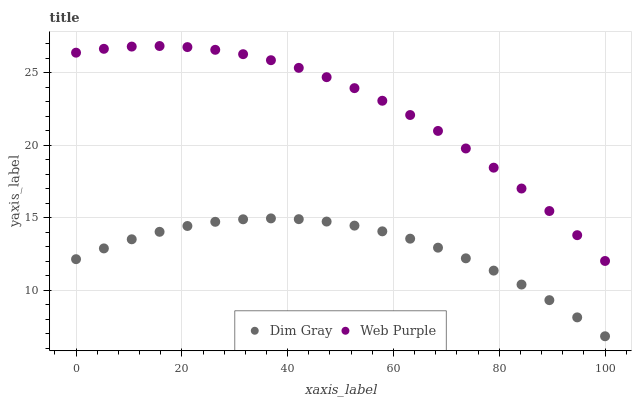Does Dim Gray have the minimum area under the curve?
Answer yes or no. Yes. Does Web Purple have the maximum area under the curve?
Answer yes or no. Yes. Does Dim Gray have the maximum area under the curve?
Answer yes or no. No. Is Dim Gray the smoothest?
Answer yes or no. Yes. Is Web Purple the roughest?
Answer yes or no. Yes. Is Dim Gray the roughest?
Answer yes or no. No. Does Dim Gray have the lowest value?
Answer yes or no. Yes. Does Web Purple have the highest value?
Answer yes or no. Yes. Does Dim Gray have the highest value?
Answer yes or no. No. Is Dim Gray less than Web Purple?
Answer yes or no. Yes. Is Web Purple greater than Dim Gray?
Answer yes or no. Yes. Does Dim Gray intersect Web Purple?
Answer yes or no. No. 